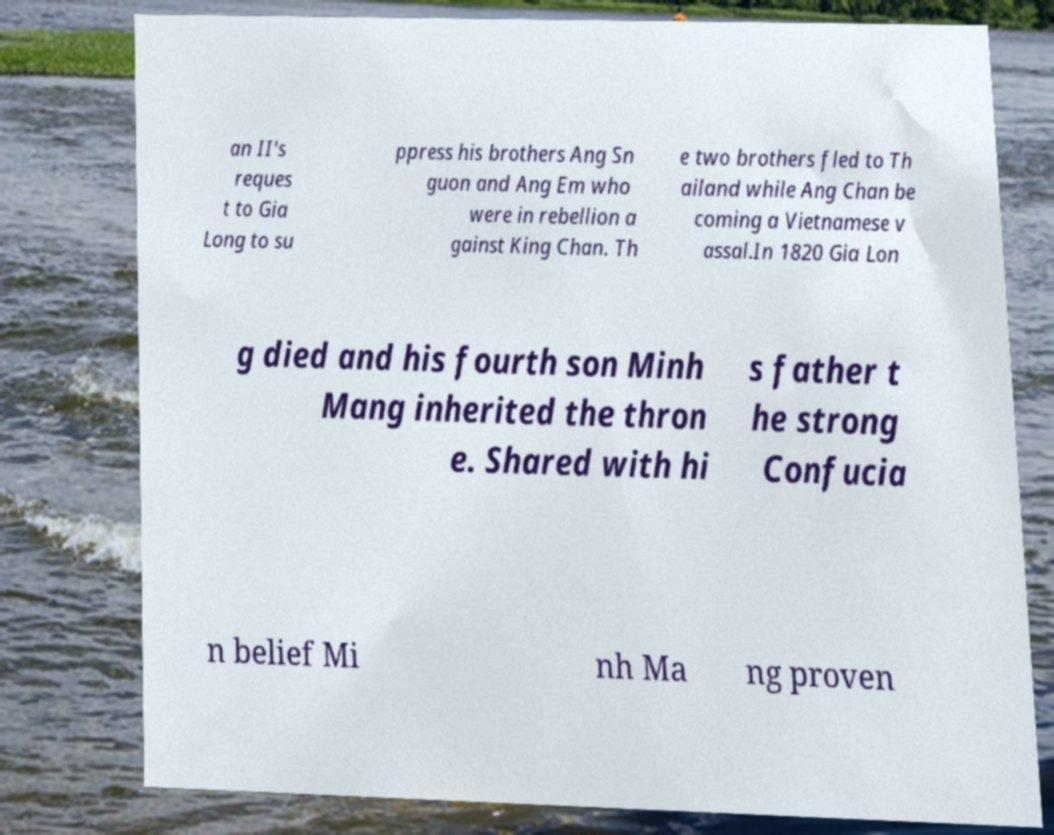Can you read and provide the text displayed in the image?This photo seems to have some interesting text. Can you extract and type it out for me? an II's reques t to Gia Long to su ppress his brothers Ang Sn guon and Ang Em who were in rebellion a gainst King Chan. Th e two brothers fled to Th ailand while Ang Chan be coming a Vietnamese v assal.In 1820 Gia Lon g died and his fourth son Minh Mang inherited the thron e. Shared with hi s father t he strong Confucia n belief Mi nh Ma ng proven 